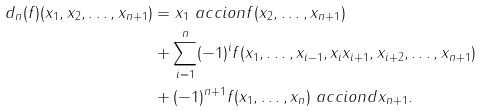<formula> <loc_0><loc_0><loc_500><loc_500>d _ { n } ( f ) ( x _ { 1 } , x _ { 2 } , \dots , x _ { n + 1 } ) & = x _ { 1 } \ a c c i o n f ( x _ { 2 } , \dots , x _ { n + 1 } ) \\ & + \sum _ { i = 1 } ^ { n } ( - 1 ) ^ { i } f ( x _ { 1 } , \dots , x _ { i - 1 } , x _ { i } x _ { i + 1 } , x _ { i + 2 } , \dots , x _ { n + 1 } ) \\ & + ( - 1 ) ^ { n + 1 } f ( x _ { 1 } , \dots , x _ { n } ) \ a c c i o n d x _ { n + 1 } .</formula> 